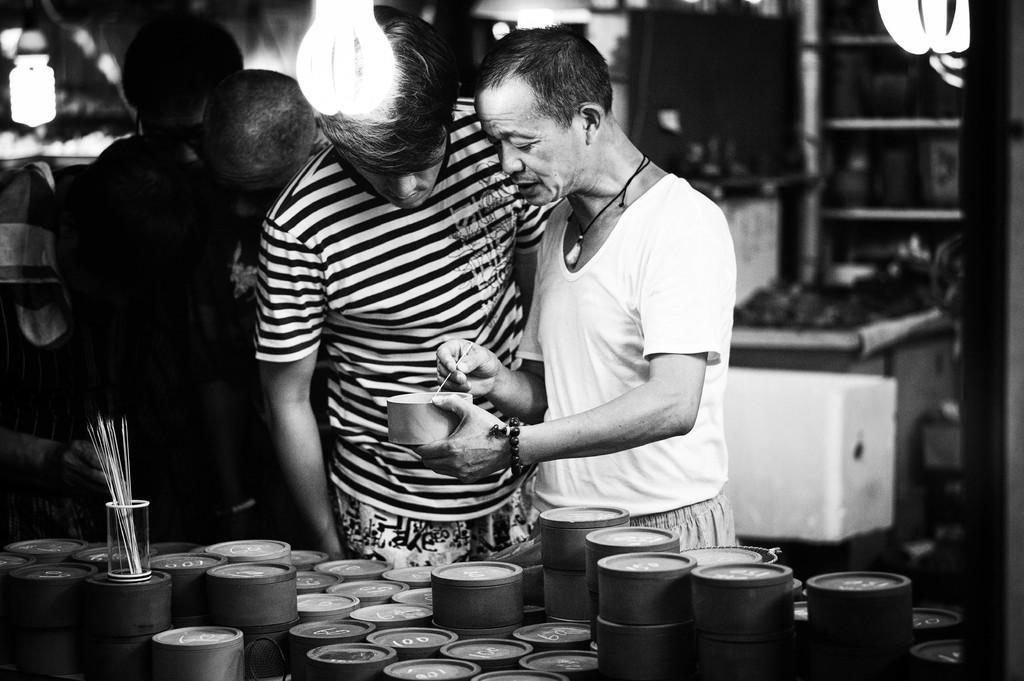Please provide a concise description of this image. This is a black and white image. In this image we can see two people. One person is holding a stick and a box. In front of them there are many boxes. Also there is a glass with sticks. Also there are lights. 